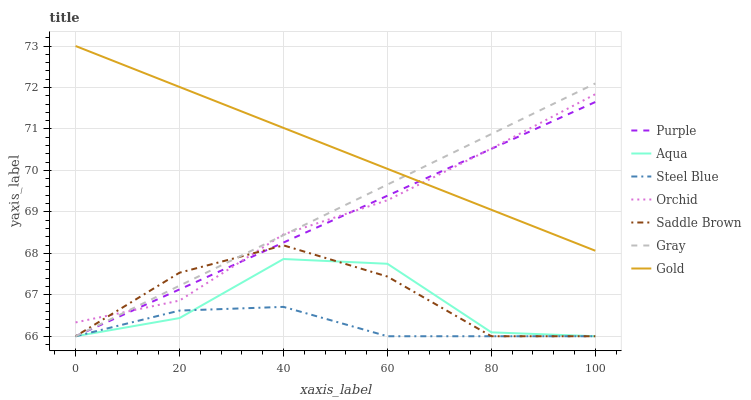Does Steel Blue have the minimum area under the curve?
Answer yes or no. Yes. Does Gold have the maximum area under the curve?
Answer yes or no. Yes. Does Purple have the minimum area under the curve?
Answer yes or no. No. Does Purple have the maximum area under the curve?
Answer yes or no. No. Is Purple the smoothest?
Answer yes or no. Yes. Is Aqua the roughest?
Answer yes or no. Yes. Is Gold the smoothest?
Answer yes or no. No. Is Gold the roughest?
Answer yes or no. No. Does Gray have the lowest value?
Answer yes or no. Yes. Does Gold have the lowest value?
Answer yes or no. No. Does Gold have the highest value?
Answer yes or no. Yes. Does Purple have the highest value?
Answer yes or no. No. Is Steel Blue less than Gold?
Answer yes or no. Yes. Is Orchid greater than Aqua?
Answer yes or no. Yes. Does Gray intersect Orchid?
Answer yes or no. Yes. Is Gray less than Orchid?
Answer yes or no. No. Is Gray greater than Orchid?
Answer yes or no. No. Does Steel Blue intersect Gold?
Answer yes or no. No. 